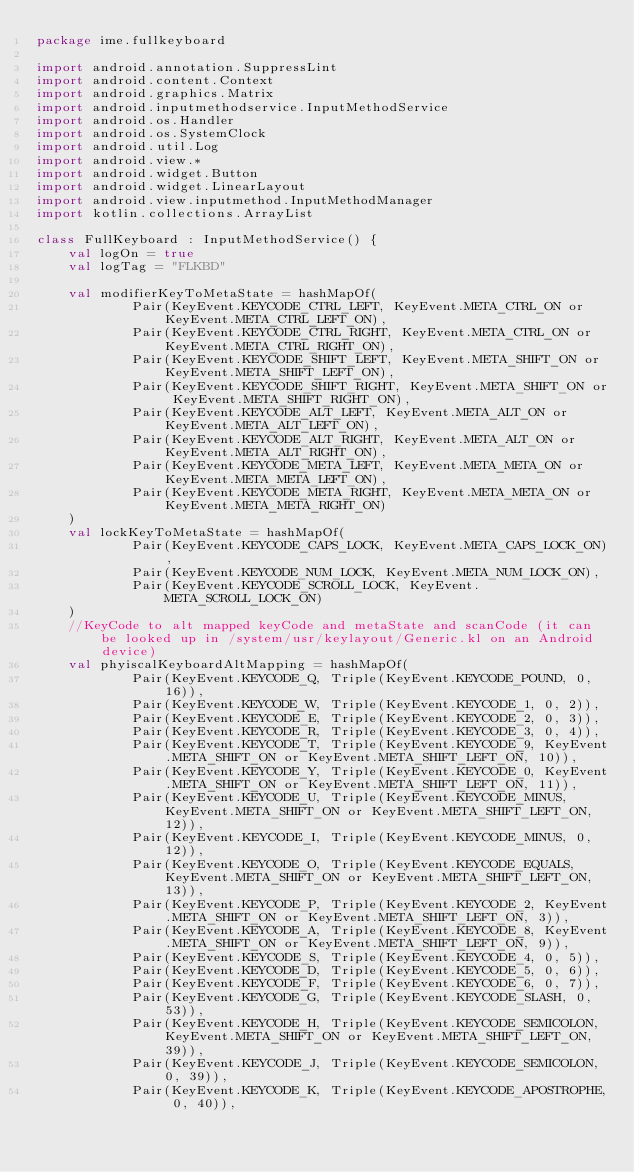<code> <loc_0><loc_0><loc_500><loc_500><_Kotlin_>package ime.fullkeyboard

import android.annotation.SuppressLint
import android.content.Context
import android.graphics.Matrix
import android.inputmethodservice.InputMethodService
import android.os.Handler
import android.os.SystemClock
import android.util.Log
import android.view.*
import android.widget.Button
import android.widget.LinearLayout
import android.view.inputmethod.InputMethodManager
import kotlin.collections.ArrayList

class FullKeyboard : InputMethodService() {
    val logOn = true
    val logTag = "FLKBD"

    val modifierKeyToMetaState = hashMapOf(
            Pair(KeyEvent.KEYCODE_CTRL_LEFT, KeyEvent.META_CTRL_ON or KeyEvent.META_CTRL_LEFT_ON),
            Pair(KeyEvent.KEYCODE_CTRL_RIGHT, KeyEvent.META_CTRL_ON or KeyEvent.META_CTRL_RIGHT_ON),
            Pair(KeyEvent.KEYCODE_SHIFT_LEFT, KeyEvent.META_SHIFT_ON or KeyEvent.META_SHIFT_LEFT_ON),
            Pair(KeyEvent.KEYCODE_SHIFT_RIGHT, KeyEvent.META_SHIFT_ON or KeyEvent.META_SHIFT_RIGHT_ON),
            Pair(KeyEvent.KEYCODE_ALT_LEFT, KeyEvent.META_ALT_ON or KeyEvent.META_ALT_LEFT_ON),
            Pair(KeyEvent.KEYCODE_ALT_RIGHT, KeyEvent.META_ALT_ON or KeyEvent.META_ALT_RIGHT_ON),
            Pair(KeyEvent.KEYCODE_META_LEFT, KeyEvent.META_META_ON or KeyEvent.META_META_LEFT_ON),
            Pair(KeyEvent.KEYCODE_META_RIGHT, KeyEvent.META_META_ON or KeyEvent.META_META_RIGHT_ON)
    )
    val lockKeyToMetaState = hashMapOf(
            Pair(KeyEvent.KEYCODE_CAPS_LOCK, KeyEvent.META_CAPS_LOCK_ON),
            Pair(KeyEvent.KEYCODE_NUM_LOCK, KeyEvent.META_NUM_LOCK_ON),
            Pair(KeyEvent.KEYCODE_SCROLL_LOCK, KeyEvent.META_SCROLL_LOCK_ON)
    )
    //KeyCode to alt mapped keyCode and metaState and scanCode (it can be looked up in /system/usr/keylayout/Generic.kl on an Android device)
    val phyiscalKeyboardAltMapping = hashMapOf(
            Pair(KeyEvent.KEYCODE_Q, Triple(KeyEvent.KEYCODE_POUND, 0, 16)),
            Pair(KeyEvent.KEYCODE_W, Triple(KeyEvent.KEYCODE_1, 0, 2)),
            Pair(KeyEvent.KEYCODE_E, Triple(KeyEvent.KEYCODE_2, 0, 3)),
            Pair(KeyEvent.KEYCODE_R, Triple(KeyEvent.KEYCODE_3, 0, 4)),
            Pair(KeyEvent.KEYCODE_T, Triple(KeyEvent.KEYCODE_9, KeyEvent.META_SHIFT_ON or KeyEvent.META_SHIFT_LEFT_ON, 10)),
            Pair(KeyEvent.KEYCODE_Y, Triple(KeyEvent.KEYCODE_0, KeyEvent.META_SHIFT_ON or KeyEvent.META_SHIFT_LEFT_ON, 11)),
            Pair(KeyEvent.KEYCODE_U, Triple(KeyEvent.KEYCODE_MINUS, KeyEvent.META_SHIFT_ON or KeyEvent.META_SHIFT_LEFT_ON, 12)),
            Pair(KeyEvent.KEYCODE_I, Triple(KeyEvent.KEYCODE_MINUS, 0, 12)),
            Pair(KeyEvent.KEYCODE_O, Triple(KeyEvent.KEYCODE_EQUALS, KeyEvent.META_SHIFT_ON or KeyEvent.META_SHIFT_LEFT_ON, 13)),
            Pair(KeyEvent.KEYCODE_P, Triple(KeyEvent.KEYCODE_2, KeyEvent.META_SHIFT_ON or KeyEvent.META_SHIFT_LEFT_ON, 3)),
            Pair(KeyEvent.KEYCODE_A, Triple(KeyEvent.KEYCODE_8, KeyEvent.META_SHIFT_ON or KeyEvent.META_SHIFT_LEFT_ON, 9)),
            Pair(KeyEvent.KEYCODE_S, Triple(KeyEvent.KEYCODE_4, 0, 5)),
            Pair(KeyEvent.KEYCODE_D, Triple(KeyEvent.KEYCODE_5, 0, 6)),
            Pair(KeyEvent.KEYCODE_F, Triple(KeyEvent.KEYCODE_6, 0, 7)),
            Pair(KeyEvent.KEYCODE_G, Triple(KeyEvent.KEYCODE_SLASH, 0, 53)),
            Pair(KeyEvent.KEYCODE_H, Triple(KeyEvent.KEYCODE_SEMICOLON, KeyEvent.META_SHIFT_ON or KeyEvent.META_SHIFT_LEFT_ON, 39)),
            Pair(KeyEvent.KEYCODE_J, Triple(KeyEvent.KEYCODE_SEMICOLON, 0, 39)),
            Pair(KeyEvent.KEYCODE_K, Triple(KeyEvent.KEYCODE_APOSTROPHE, 0, 40)),</code> 